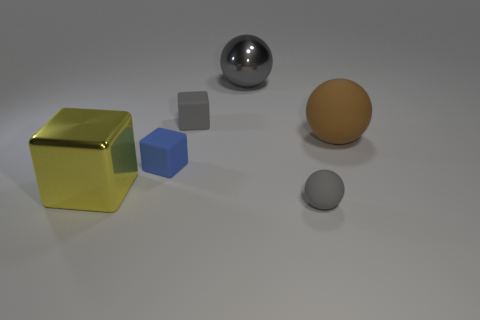There is a metallic sphere that is the same color as the small matte sphere; what size is it?
Ensure brevity in your answer.  Large. What is the size of the ball that is both in front of the large gray sphere and behind the small gray rubber ball?
Make the answer very short. Large. What is the color of the big object that is the same shape as the tiny blue matte object?
Ensure brevity in your answer.  Yellow. Are there more blue things in front of the gray cube than large yellow metal things that are on the right side of the blue thing?
Give a very brief answer. Yes. What number of other things are there of the same shape as the yellow metallic thing?
Provide a succinct answer. 2. There is a gray ball in front of the large yellow cube; is there a gray metallic object that is in front of it?
Offer a very short reply. No. What number of small metallic spheres are there?
Your answer should be very brief. 0. There is a tiny matte sphere; is it the same color as the shiny thing that is right of the big yellow shiny cube?
Offer a very short reply. Yes. Are there more red matte cylinders than blue matte objects?
Keep it short and to the point. No. Is there any other thing that is the same color as the tiny sphere?
Keep it short and to the point. Yes. 